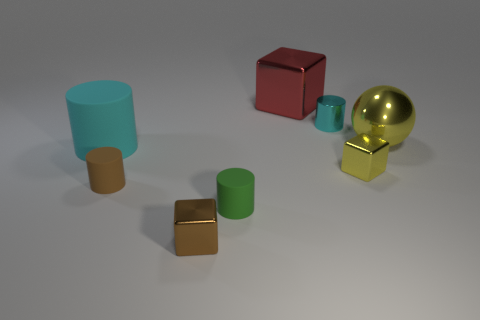How many tiny things are both in front of the tiny brown matte thing and behind the large cyan thing? 0 